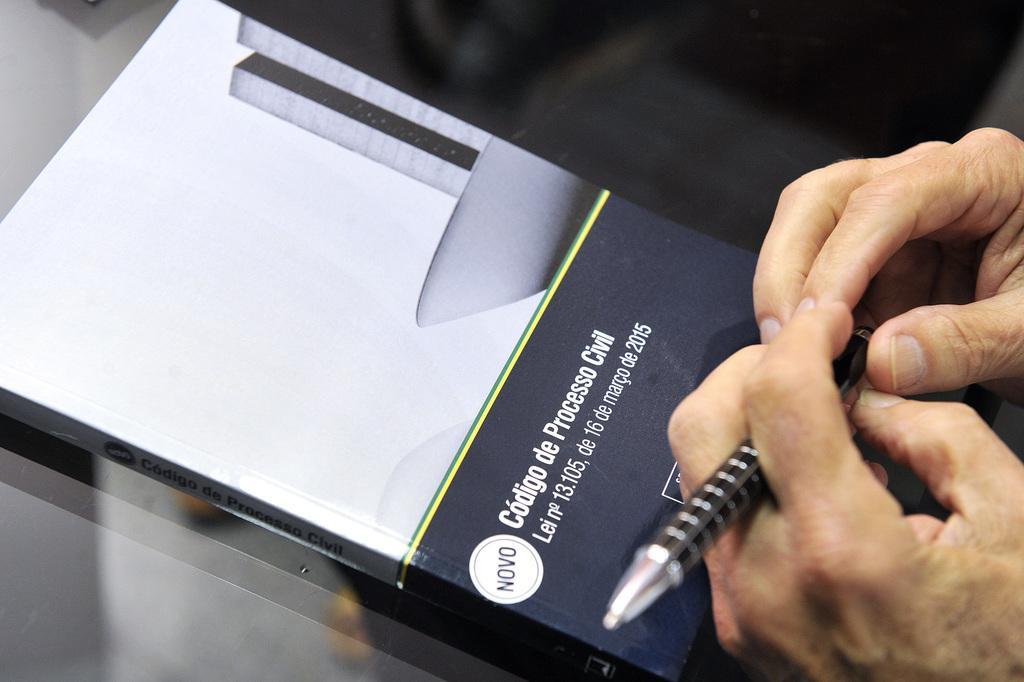Could you give a brief overview of what you see in this image? In the center of the image we can see book, pen, person's hand on the table. 